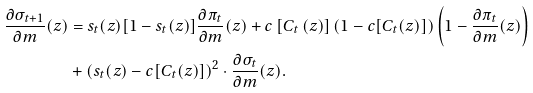<formula> <loc_0><loc_0><loc_500><loc_500>\frac { \partial \sigma _ { t + 1 } } { \partial m } ( z ) & = s _ { t } ( z ) [ 1 - s _ { t } ( z ) ] \frac { \partial \pi _ { t } } { \partial m } ( z ) + c \left [ C _ { t } \left ( z \right ) \right ] ( 1 - c [ C _ { t } ( z ) ] ) \left ( 1 - \frac { \partial \pi _ { t } } { \partial m } ( z ) \right ) \\ & + ( s _ { t } ( z ) - c [ C _ { t } ( z ) ] ) ^ { 2 } \cdot \frac { \partial \sigma _ { t } } { \partial m } ( z ) .</formula> 